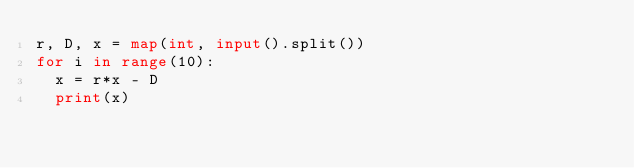Convert code to text. <code><loc_0><loc_0><loc_500><loc_500><_Python_>r, D, x = map(int, input().split())
for i in range(10):
  x = r*x - D
  print(x)</code> 